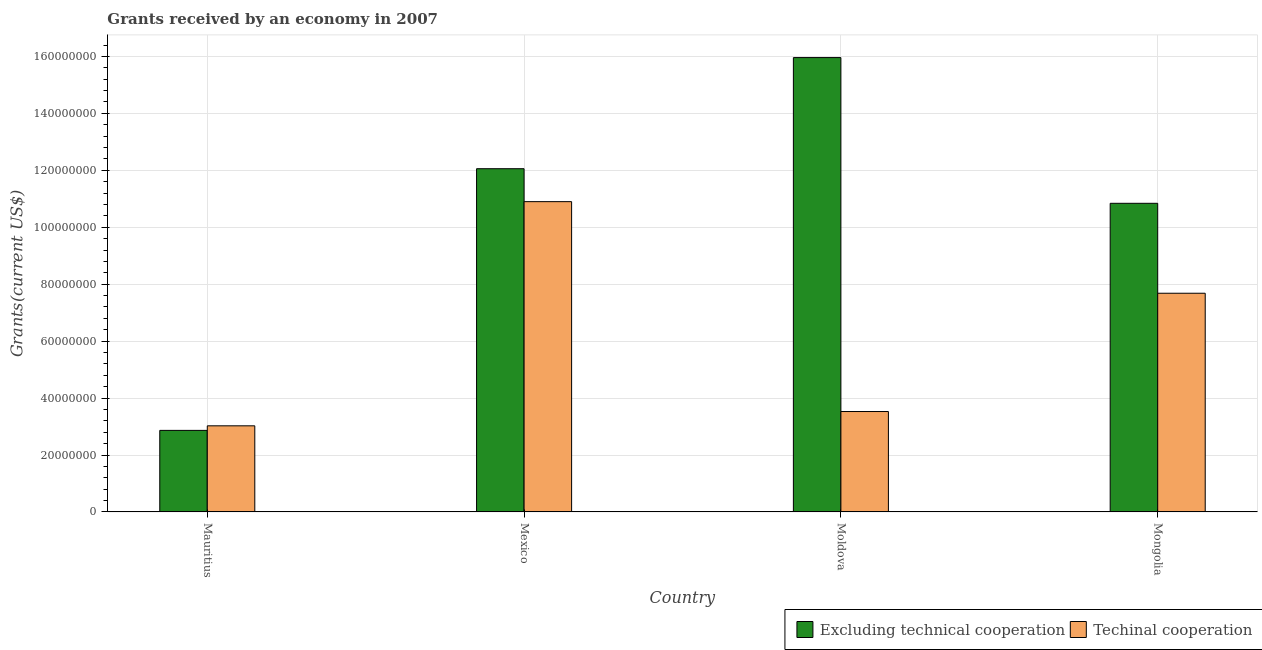How many different coloured bars are there?
Offer a terse response. 2. How many groups of bars are there?
Your answer should be very brief. 4. Are the number of bars on each tick of the X-axis equal?
Offer a very short reply. Yes. How many bars are there on the 2nd tick from the left?
Your response must be concise. 2. How many bars are there on the 3rd tick from the right?
Ensure brevity in your answer.  2. What is the amount of grants received(excluding technical cooperation) in Mauritius?
Make the answer very short. 2.86e+07. Across all countries, what is the maximum amount of grants received(excluding technical cooperation)?
Your answer should be compact. 1.60e+08. Across all countries, what is the minimum amount of grants received(including technical cooperation)?
Make the answer very short. 3.02e+07. In which country was the amount of grants received(excluding technical cooperation) maximum?
Ensure brevity in your answer.  Moldova. In which country was the amount of grants received(excluding technical cooperation) minimum?
Offer a very short reply. Mauritius. What is the total amount of grants received(including technical cooperation) in the graph?
Offer a terse response. 2.51e+08. What is the difference between the amount of grants received(including technical cooperation) in Mexico and that in Moldova?
Give a very brief answer. 7.37e+07. What is the difference between the amount of grants received(including technical cooperation) in Mauritius and the amount of grants received(excluding technical cooperation) in Mongolia?
Your answer should be compact. -7.82e+07. What is the average amount of grants received(excluding technical cooperation) per country?
Ensure brevity in your answer.  1.04e+08. What is the difference between the amount of grants received(excluding technical cooperation) and amount of grants received(including technical cooperation) in Mexico?
Your response must be concise. 1.16e+07. What is the ratio of the amount of grants received(including technical cooperation) in Mexico to that in Moldova?
Your response must be concise. 3.09. What is the difference between the highest and the second highest amount of grants received(including technical cooperation)?
Give a very brief answer. 3.22e+07. What is the difference between the highest and the lowest amount of grants received(excluding technical cooperation)?
Keep it short and to the point. 1.31e+08. In how many countries, is the amount of grants received(including technical cooperation) greater than the average amount of grants received(including technical cooperation) taken over all countries?
Your response must be concise. 2. What does the 1st bar from the left in Moldova represents?
Keep it short and to the point. Excluding technical cooperation. What does the 2nd bar from the right in Moldova represents?
Provide a succinct answer. Excluding technical cooperation. How many bars are there?
Offer a very short reply. 8. Are the values on the major ticks of Y-axis written in scientific E-notation?
Provide a short and direct response. No. Where does the legend appear in the graph?
Keep it short and to the point. Bottom right. What is the title of the graph?
Keep it short and to the point. Grants received by an economy in 2007. What is the label or title of the Y-axis?
Make the answer very short. Grants(current US$). What is the Grants(current US$) in Excluding technical cooperation in Mauritius?
Offer a terse response. 2.86e+07. What is the Grants(current US$) of Techinal cooperation in Mauritius?
Offer a very short reply. 3.02e+07. What is the Grants(current US$) of Excluding technical cooperation in Mexico?
Your answer should be very brief. 1.21e+08. What is the Grants(current US$) in Techinal cooperation in Mexico?
Provide a succinct answer. 1.09e+08. What is the Grants(current US$) of Excluding technical cooperation in Moldova?
Your answer should be very brief. 1.60e+08. What is the Grants(current US$) of Techinal cooperation in Moldova?
Provide a short and direct response. 3.53e+07. What is the Grants(current US$) in Excluding technical cooperation in Mongolia?
Give a very brief answer. 1.08e+08. What is the Grants(current US$) in Techinal cooperation in Mongolia?
Your response must be concise. 7.68e+07. Across all countries, what is the maximum Grants(current US$) in Excluding technical cooperation?
Provide a short and direct response. 1.60e+08. Across all countries, what is the maximum Grants(current US$) of Techinal cooperation?
Make the answer very short. 1.09e+08. Across all countries, what is the minimum Grants(current US$) in Excluding technical cooperation?
Provide a short and direct response. 2.86e+07. Across all countries, what is the minimum Grants(current US$) of Techinal cooperation?
Make the answer very short. 3.02e+07. What is the total Grants(current US$) of Excluding technical cooperation in the graph?
Provide a short and direct response. 4.17e+08. What is the total Grants(current US$) in Techinal cooperation in the graph?
Your answer should be compact. 2.51e+08. What is the difference between the Grants(current US$) of Excluding technical cooperation in Mauritius and that in Mexico?
Provide a short and direct response. -9.19e+07. What is the difference between the Grants(current US$) of Techinal cooperation in Mauritius and that in Mexico?
Keep it short and to the point. -7.87e+07. What is the difference between the Grants(current US$) of Excluding technical cooperation in Mauritius and that in Moldova?
Your answer should be very brief. -1.31e+08. What is the difference between the Grants(current US$) of Techinal cooperation in Mauritius and that in Moldova?
Your response must be concise. -5.02e+06. What is the difference between the Grants(current US$) of Excluding technical cooperation in Mauritius and that in Mongolia?
Offer a terse response. -7.98e+07. What is the difference between the Grants(current US$) in Techinal cooperation in Mauritius and that in Mongolia?
Offer a very short reply. -4.66e+07. What is the difference between the Grants(current US$) in Excluding technical cooperation in Mexico and that in Moldova?
Give a very brief answer. -3.90e+07. What is the difference between the Grants(current US$) in Techinal cooperation in Mexico and that in Moldova?
Offer a terse response. 7.37e+07. What is the difference between the Grants(current US$) in Excluding technical cooperation in Mexico and that in Mongolia?
Your response must be concise. 1.22e+07. What is the difference between the Grants(current US$) of Techinal cooperation in Mexico and that in Mongolia?
Give a very brief answer. 3.22e+07. What is the difference between the Grants(current US$) in Excluding technical cooperation in Moldova and that in Mongolia?
Offer a terse response. 5.12e+07. What is the difference between the Grants(current US$) in Techinal cooperation in Moldova and that in Mongolia?
Provide a succinct answer. -4.16e+07. What is the difference between the Grants(current US$) in Excluding technical cooperation in Mauritius and the Grants(current US$) in Techinal cooperation in Mexico?
Ensure brevity in your answer.  -8.03e+07. What is the difference between the Grants(current US$) in Excluding technical cooperation in Mauritius and the Grants(current US$) in Techinal cooperation in Moldova?
Your response must be concise. -6.62e+06. What is the difference between the Grants(current US$) in Excluding technical cooperation in Mauritius and the Grants(current US$) in Techinal cooperation in Mongolia?
Offer a very short reply. -4.82e+07. What is the difference between the Grants(current US$) in Excluding technical cooperation in Mexico and the Grants(current US$) in Techinal cooperation in Moldova?
Give a very brief answer. 8.53e+07. What is the difference between the Grants(current US$) in Excluding technical cooperation in Mexico and the Grants(current US$) in Techinal cooperation in Mongolia?
Provide a short and direct response. 4.37e+07. What is the difference between the Grants(current US$) of Excluding technical cooperation in Moldova and the Grants(current US$) of Techinal cooperation in Mongolia?
Make the answer very short. 8.28e+07. What is the average Grants(current US$) of Excluding technical cooperation per country?
Ensure brevity in your answer.  1.04e+08. What is the average Grants(current US$) of Techinal cooperation per country?
Your response must be concise. 6.28e+07. What is the difference between the Grants(current US$) in Excluding technical cooperation and Grants(current US$) in Techinal cooperation in Mauritius?
Provide a short and direct response. -1.60e+06. What is the difference between the Grants(current US$) in Excluding technical cooperation and Grants(current US$) in Techinal cooperation in Mexico?
Your response must be concise. 1.16e+07. What is the difference between the Grants(current US$) of Excluding technical cooperation and Grants(current US$) of Techinal cooperation in Moldova?
Offer a terse response. 1.24e+08. What is the difference between the Grants(current US$) in Excluding technical cooperation and Grants(current US$) in Techinal cooperation in Mongolia?
Give a very brief answer. 3.16e+07. What is the ratio of the Grants(current US$) in Excluding technical cooperation in Mauritius to that in Mexico?
Your answer should be compact. 0.24. What is the ratio of the Grants(current US$) of Techinal cooperation in Mauritius to that in Mexico?
Ensure brevity in your answer.  0.28. What is the ratio of the Grants(current US$) of Excluding technical cooperation in Mauritius to that in Moldova?
Offer a terse response. 0.18. What is the ratio of the Grants(current US$) of Techinal cooperation in Mauritius to that in Moldova?
Keep it short and to the point. 0.86. What is the ratio of the Grants(current US$) in Excluding technical cooperation in Mauritius to that in Mongolia?
Provide a succinct answer. 0.26. What is the ratio of the Grants(current US$) in Techinal cooperation in Mauritius to that in Mongolia?
Your response must be concise. 0.39. What is the ratio of the Grants(current US$) in Excluding technical cooperation in Mexico to that in Moldova?
Give a very brief answer. 0.76. What is the ratio of the Grants(current US$) in Techinal cooperation in Mexico to that in Moldova?
Keep it short and to the point. 3.09. What is the ratio of the Grants(current US$) of Excluding technical cooperation in Mexico to that in Mongolia?
Offer a very short reply. 1.11. What is the ratio of the Grants(current US$) in Techinal cooperation in Mexico to that in Mongolia?
Offer a very short reply. 1.42. What is the ratio of the Grants(current US$) in Excluding technical cooperation in Moldova to that in Mongolia?
Keep it short and to the point. 1.47. What is the ratio of the Grants(current US$) in Techinal cooperation in Moldova to that in Mongolia?
Provide a short and direct response. 0.46. What is the difference between the highest and the second highest Grants(current US$) in Excluding technical cooperation?
Your answer should be compact. 3.90e+07. What is the difference between the highest and the second highest Grants(current US$) of Techinal cooperation?
Your answer should be very brief. 3.22e+07. What is the difference between the highest and the lowest Grants(current US$) in Excluding technical cooperation?
Your answer should be very brief. 1.31e+08. What is the difference between the highest and the lowest Grants(current US$) of Techinal cooperation?
Make the answer very short. 7.87e+07. 